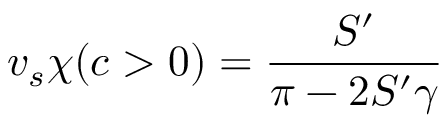Convert formula to latex. <formula><loc_0><loc_0><loc_500><loc_500>v _ { s } \chi ( c > 0 ) = \frac { S ^ { \prime } } { \pi - 2 S ^ { \prime } \gamma }</formula> 